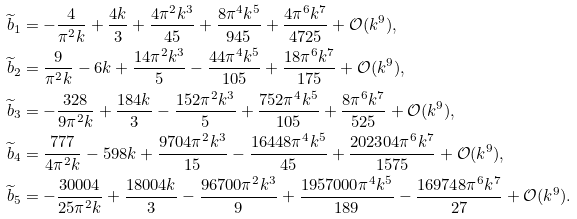<formula> <loc_0><loc_0><loc_500><loc_500>& \widetilde { b } _ { 1 } = - \frac { 4 } { \pi ^ { 2 } k } + \frac { 4 k } { 3 } + \frac { 4 \pi ^ { 2 } k ^ { 3 } } { 4 5 } + \frac { 8 \pi ^ { 4 } k ^ { 5 } } { 9 4 5 } + \frac { 4 \pi ^ { 6 } k ^ { 7 } } { 4 7 2 5 } + { \mathcal { O } } ( k ^ { 9 } ) , \\ & \widetilde { b } _ { 2 } = \frac { 9 } { \pi ^ { 2 } k } - 6 k + \frac { 1 4 \pi ^ { 2 } k ^ { 3 } } { 5 } - \frac { 4 4 \pi ^ { 4 } k ^ { 5 } } { 1 0 5 } + \frac { 1 8 \pi ^ { 6 } k ^ { 7 } } { 1 7 5 } + { \mathcal { O } } ( k ^ { 9 } ) , \\ & \widetilde { b } _ { 3 } = - \frac { 3 2 8 } { 9 \pi ^ { 2 } k } + \frac { 1 8 4 k } { 3 } - \frac { 1 5 2 \pi ^ { 2 } k ^ { 3 } } { 5 } + \frac { 7 5 2 \pi ^ { 4 } k ^ { 5 } } { 1 0 5 } + \frac { 8 \pi ^ { 6 } k ^ { 7 } } { 5 2 5 } + { \mathcal { O } } ( k ^ { 9 } ) , \\ & \widetilde { b } _ { 4 } = \frac { 7 7 7 } { 4 \pi ^ { 2 } k } - 5 9 8 k + \frac { 9 7 0 4 \pi ^ { 2 } k ^ { 3 } } { 1 5 } - \frac { 1 6 4 4 8 \pi ^ { 4 } k ^ { 5 } } { 4 5 } + \frac { 2 0 2 3 0 4 \pi ^ { 6 } k ^ { 7 } } { 1 5 7 5 } + { \mathcal { O } } ( k ^ { 9 } ) , \\ & \widetilde { b } _ { 5 } = - \frac { 3 0 0 0 4 } { 2 5 \pi ^ { 2 } k } + \frac { 1 8 0 0 4 k } { 3 } - \frac { 9 6 7 0 0 \pi ^ { 2 } k ^ { 3 } } { 9 } + \frac { 1 9 5 7 0 0 0 \pi ^ { 4 } k ^ { 5 } } { 1 8 9 } - \frac { 1 6 9 7 4 8 \pi ^ { 6 } k ^ { 7 } } { 2 7 } + { \mathcal { O } } ( k ^ { 9 } ) .</formula> 